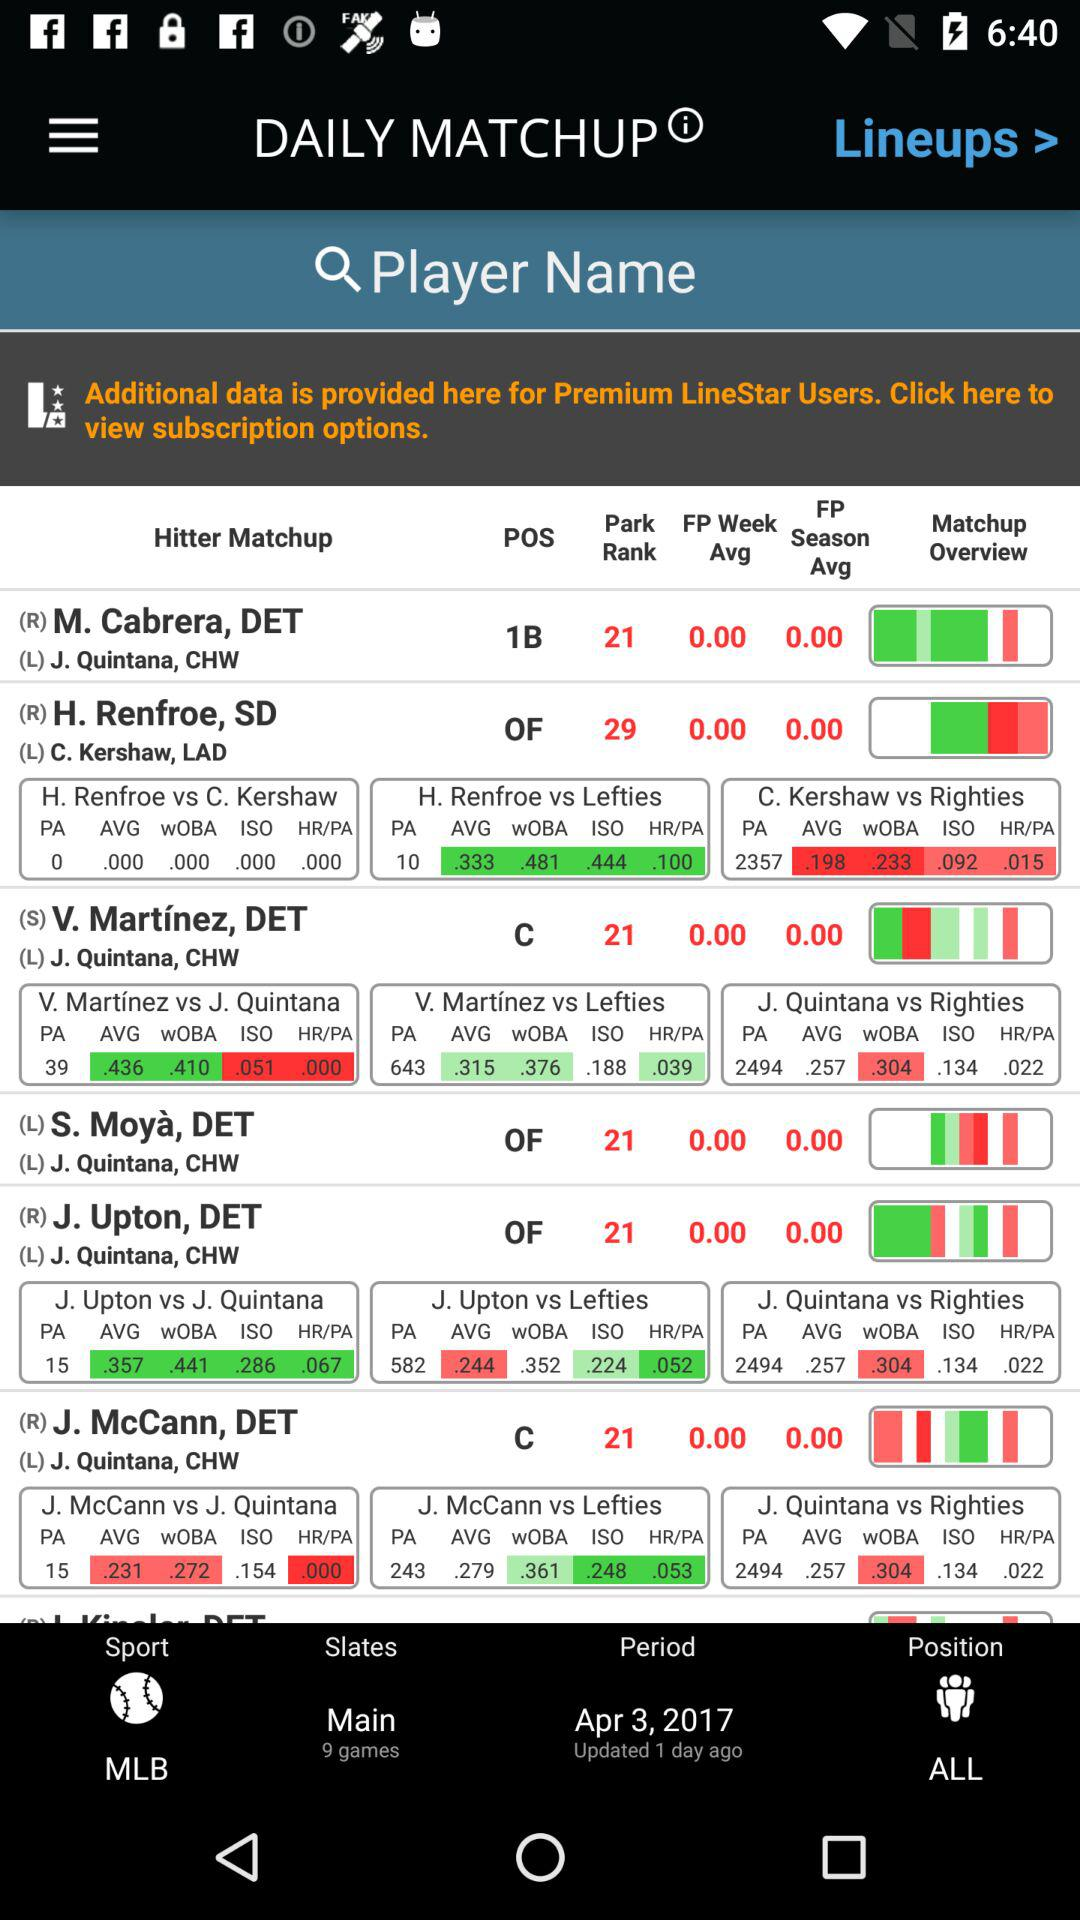How many main games in total are there? There are 9 main games in total. 